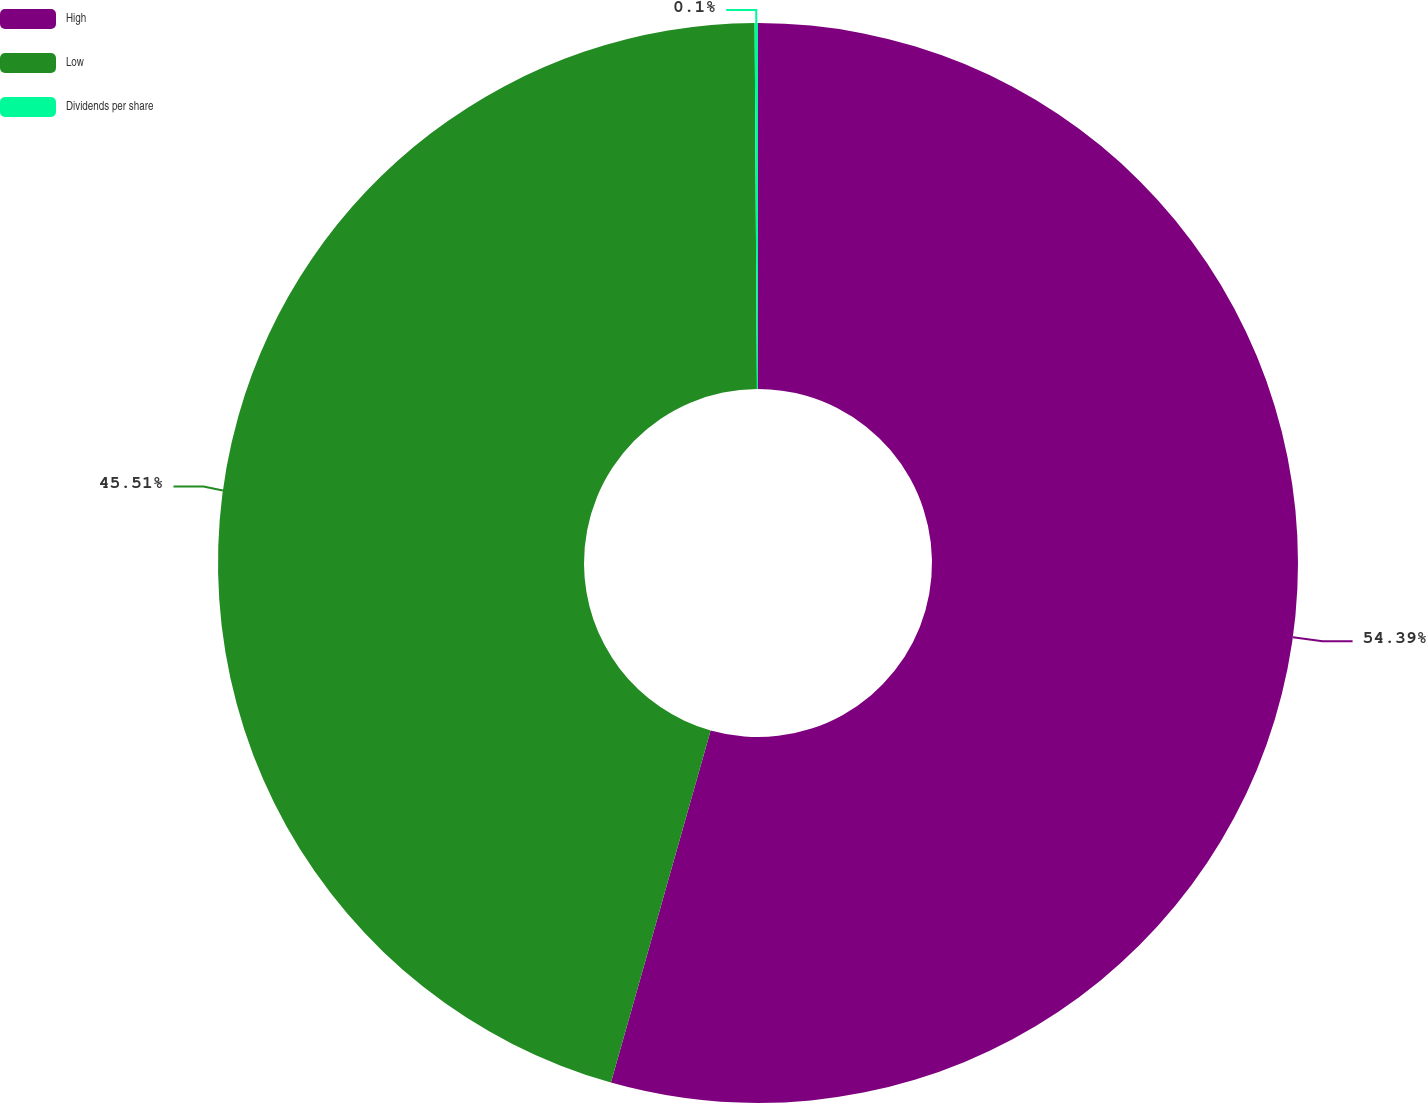Convert chart to OTSL. <chart><loc_0><loc_0><loc_500><loc_500><pie_chart><fcel>High<fcel>Low<fcel>Dividends per share<nl><fcel>54.39%<fcel>45.51%<fcel>0.1%<nl></chart> 